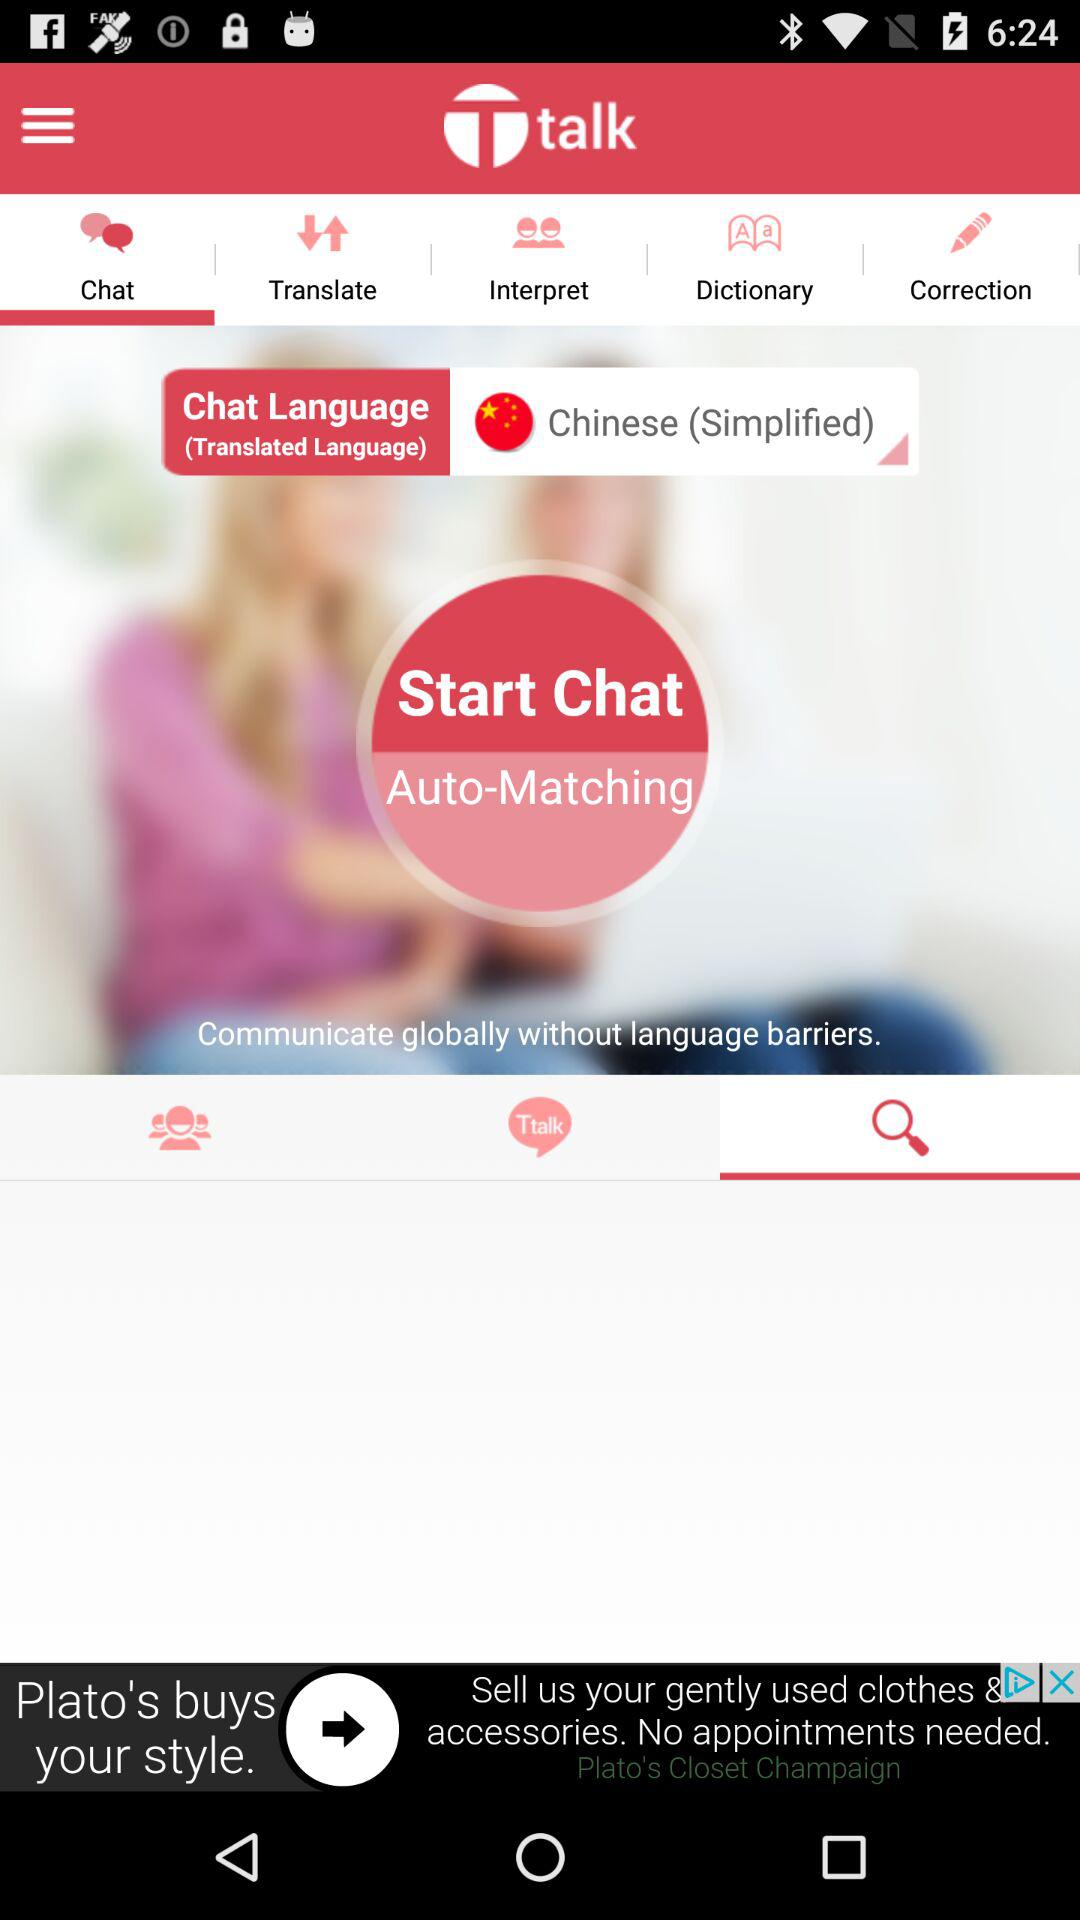Which tab is currently selected at the top? The currently selected tab at the top is "Chat". 